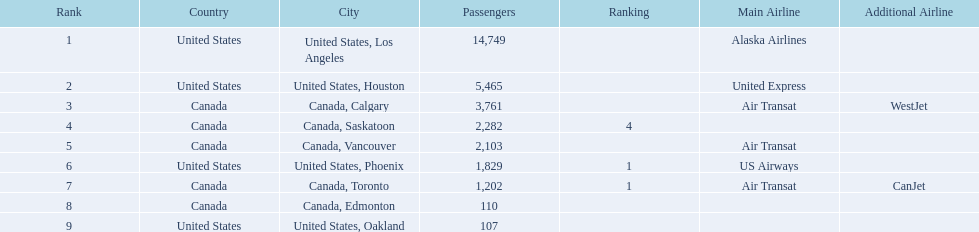What were all the passenger totals? 14,749, 5,465, 3,761, 2,282, 2,103, 1,829, 1,202, 110, 107. Which of these were to los angeles? 14,749. What other destination combined with this is closest to 19,000? Canada, Calgary. 